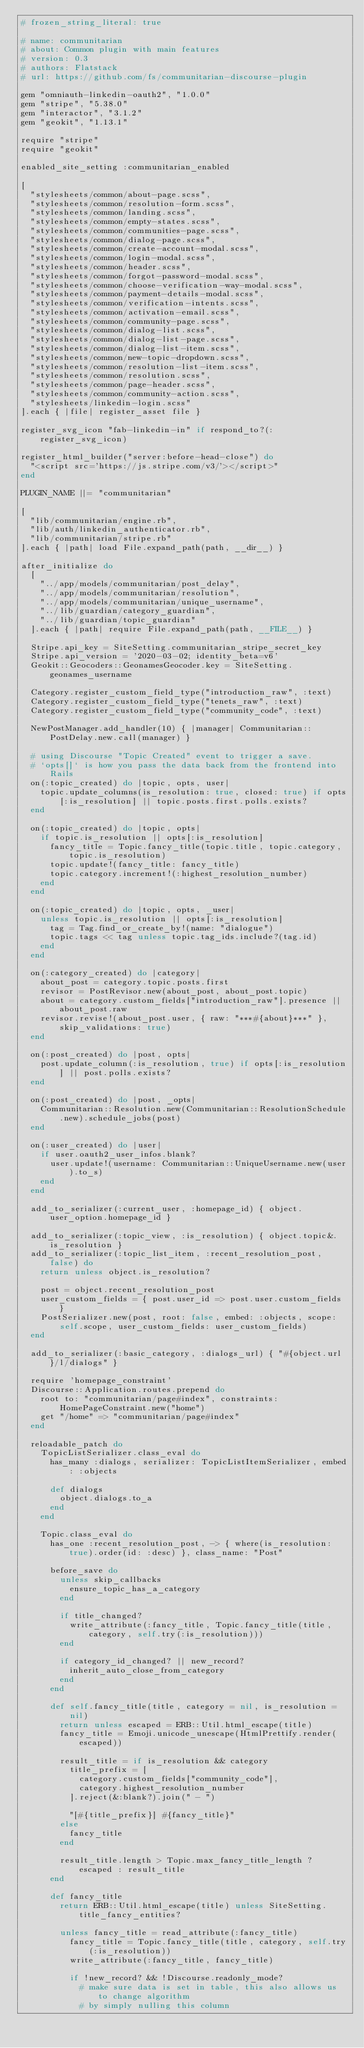<code> <loc_0><loc_0><loc_500><loc_500><_Ruby_># frozen_string_literal: true

# name: communitarian
# about: Common plugin with main features
# version: 0.3
# authors: Flatstack
# url: https://github.com/fs/communitarian-discourse-plugin

gem "omniauth-linkedin-oauth2", "1.0.0"
gem "stripe", "5.38.0"
gem "interactor", "3.1.2"
gem "geokit", "1.13.1"

require "stripe"
require "geokit"

enabled_site_setting :communitarian_enabled

[
  "stylesheets/common/about-page.scss",
  "stylesheets/common/resolution-form.scss",
  "stylesheets/common/landing.scss",
  "stylesheets/common/empty-states.scss",
  "stylesheets/common/communities-page.scss",
  "stylesheets/common/dialog-page.scss",
  "stylesheets/common/create-account-modal.scss",
  "stylesheets/common/login-modal.scss",
  "stylesheets/common/header.scss",
  "stylesheets/common/forgot-password-modal.scss",
  "stylesheets/common/choose-verification-way-modal.scss",
  "stylesheets/common/payment-details-modal.scss",
  "stylesheets/common/verification-intents.scss",
  "stylesheets/common/activation-email.scss",
  "stylesheets/common/community-page.scss",
  "stylesheets/common/dialog-list.scss",
  "stylesheets/common/dialog-list-page.scss",
  "stylesheets/common/dialog-list-item.scss",
  "stylesheets/common/new-topic-dropdown.scss",
  "stylesheets/common/resolution-list-item.scss",
  "stylesheets/common/resolution.scss",
  "stylesheets/common/page-header.scss",
  "stylesheets/common/community-action.scss",
  "stylesheets/linkedin-login.scss"
].each { |file| register_asset file }

register_svg_icon "fab-linkedin-in" if respond_to?(:register_svg_icon)

register_html_builder("server:before-head-close") do
  "<script src='https://js.stripe.com/v3/'></script>"
end

PLUGIN_NAME ||= "communitarian"

[
  "lib/communitarian/engine.rb",
  "lib/auth/linkedin_authenticator.rb",
  "lib/communitarian/stripe.rb"
].each { |path| load File.expand_path(path, __dir__) }

after_initialize do
  [
    "../app/models/communitarian/post_delay",
    "../app/models/communitarian/resolution",
    "../app/models/communitarian/unique_username",
    "../lib/guardian/category_guardian",
    "../lib/guardian/topic_guardian"
  ].each { |path| require File.expand_path(path, __FILE__) }

  Stripe.api_key = SiteSetting.communitarian_stripe_secret_key
  Stripe.api_version = '2020-03-02; identity_beta=v6'
  Geokit::Geocoders::GeonamesGeocoder.key = SiteSetting.geonames_username

  Category.register_custom_field_type("introduction_raw", :text)
  Category.register_custom_field_type("tenets_raw", :text)
  Category.register_custom_field_type("community_code", :text)

  NewPostManager.add_handler(10) { |manager| Communitarian::PostDelay.new.call(manager) }

  # using Discourse "Topic Created" event to trigger a save.
  # `opts[]` is how you pass the data back from the frontend into Rails
  on(:topic_created) do |topic, opts, user|
    topic.update_columns(is_resolution: true, closed: true) if opts[:is_resolution] || topic.posts.first.polls.exists?
  end

  on(:topic_created) do |topic, opts|
    if topic.is_resolution || opts[:is_resolution]
      fancy_title = Topic.fancy_title(topic.title, topic.category, topic.is_resolution)
      topic.update!(fancy_title: fancy_title)
      topic.category.increment!(:highest_resolution_number)
    end
  end

  on(:topic_created) do |topic, opts, _user|
    unless topic.is_resolution || opts[:is_resolution]
      tag = Tag.find_or_create_by!(name: "dialogue")
      topic.tags << tag unless topic.tag_ids.include?(tag.id)
    end
  end

  on(:category_created) do |category|
    about_post = category.topic.posts.first
    revisor = PostRevisor.new(about_post, about_post.topic)
    about = category.custom_fields["introduction_raw"].presence || about_post.raw
    revisor.revise!(about_post.user, { raw: "***#{about}***" }, skip_validations: true)
  end

  on(:post_created) do |post, opts|
    post.update_column(:is_resolution, true) if opts[:is_resolution] || post.polls.exists?
  end

  on(:post_created) do |post, _opts|
    Communitarian::Resolution.new(Communitarian::ResolutionSchedule.new).schedule_jobs(post)
  end

  on(:user_created) do |user|
    if user.oauth2_user_infos.blank?
      user.update!(username: Communitarian::UniqueUsername.new(user).to_s)
    end
  end

  add_to_serializer(:current_user, :homepage_id) { object.user_option.homepage_id }

  add_to_serializer(:topic_view, :is_resolution) { object.topic&.is_resolution }
  add_to_serializer(:topic_list_item, :recent_resolution_post, false) do
    return unless object.is_resolution?

    post = object.recent_resolution_post
    user_custom_fields = { post.user_id => post.user.custom_fields }
    PostSerializer.new(post, root: false, embed: :objects, scope: self.scope, user_custom_fields: user_custom_fields)
  end

  add_to_serializer(:basic_category, :dialogs_url) { "#{object.url}/l/dialogs" }

  require 'homepage_constraint'
  Discourse::Application.routes.prepend do
    root to: "communitarian/page#index", constraints: HomePageConstraint.new("home")
    get "/home" => "communitarian/page#index"
  end

  reloadable_patch do
    TopicListSerializer.class_eval do
      has_many :dialogs, serializer: TopicListItemSerializer, embed: :objects

      def dialogs
        object.dialogs.to_a
      end
    end

    Topic.class_eval do
      has_one :recent_resolution_post, -> { where(is_resolution: true).order(id: :desc) }, class_name: "Post"

      before_save do
        unless skip_callbacks
          ensure_topic_has_a_category
        end

        if title_changed?
          write_attribute(:fancy_title, Topic.fancy_title(title, category, self.try(:is_resolution)))
        end

        if category_id_changed? || new_record?
          inherit_auto_close_from_category
        end
      end

      def self.fancy_title(title, category = nil, is_resolution = nil)
        return unless escaped = ERB::Util.html_escape(title)
        fancy_title = Emoji.unicode_unescape(HtmlPrettify.render(escaped))

        result_title = if is_resolution && category
          title_prefix = [
            category.custom_fields["community_code"],
            category.highest_resolution_number
          ].reject(&:blank?).join(" - ")

          "[#{title_prefix}] #{fancy_title}"
        else
          fancy_title
        end

        result_title.length > Topic.max_fancy_title_length ? escaped : result_title
      end

      def fancy_title
        return ERB::Util.html_escape(title) unless SiteSetting.title_fancy_entities?

        unless fancy_title = read_attribute(:fancy_title)
          fancy_title = Topic.fancy_title(title, category, self.try(:is_resolution))
          write_attribute(:fancy_title, fancy_title)

          if !new_record? && !Discourse.readonly_mode?
            # make sure data is set in table, this also allows us to change algorithm
            # by simply nulling this column</code> 